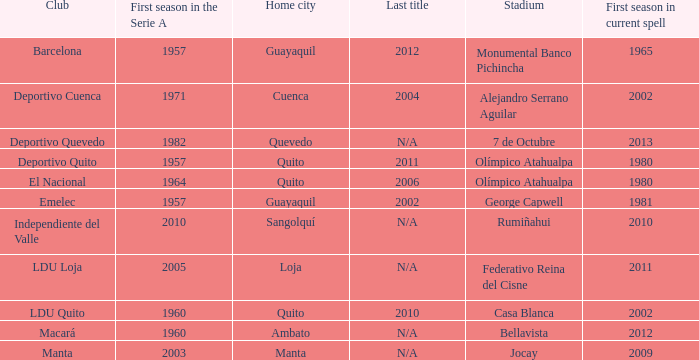Name the most for first season in the serie a for 7 de octubre 1982.0. 